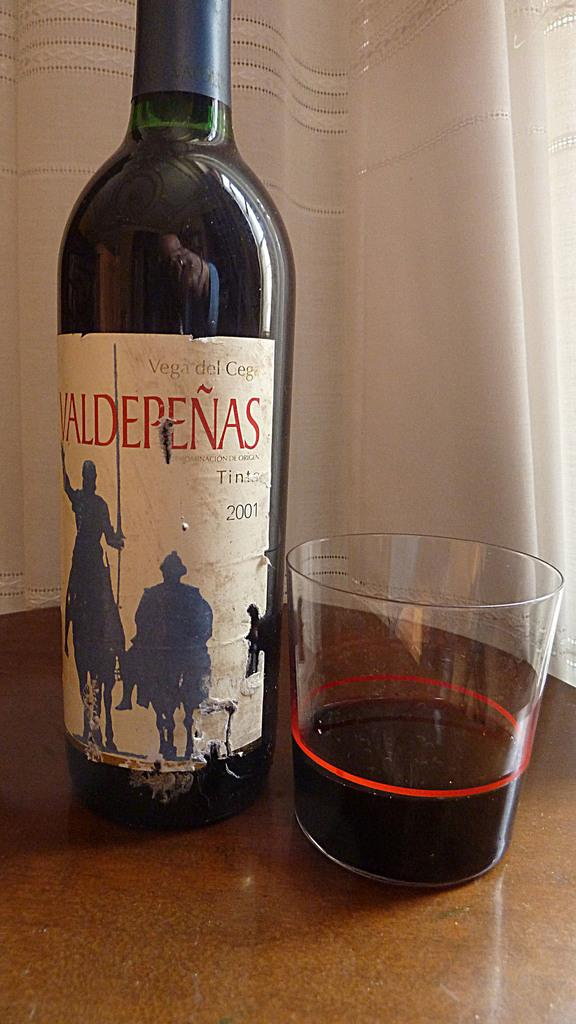<image>
Offer a succinct explanation of the picture presented. A wine bottle from 2001 is next to a glass with wine in it. 